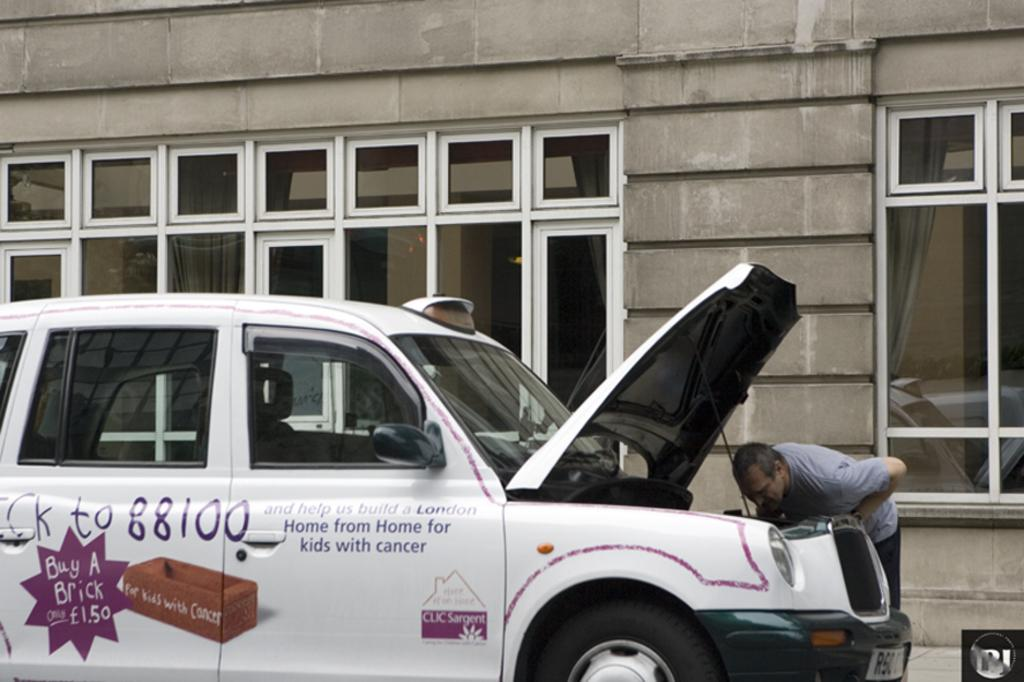<image>
Render a clear and concise summary of the photo. person looking under a hood for a car saying 88100 on the isde. 